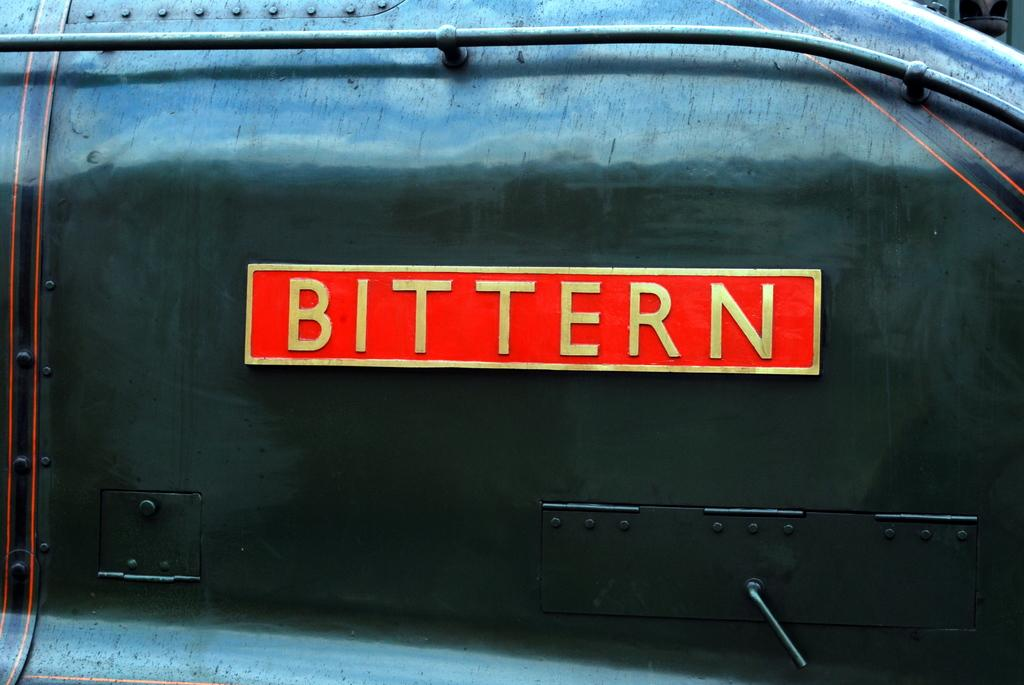<image>
Provide a brief description of the given image. a bittern sign on the side of a bag 